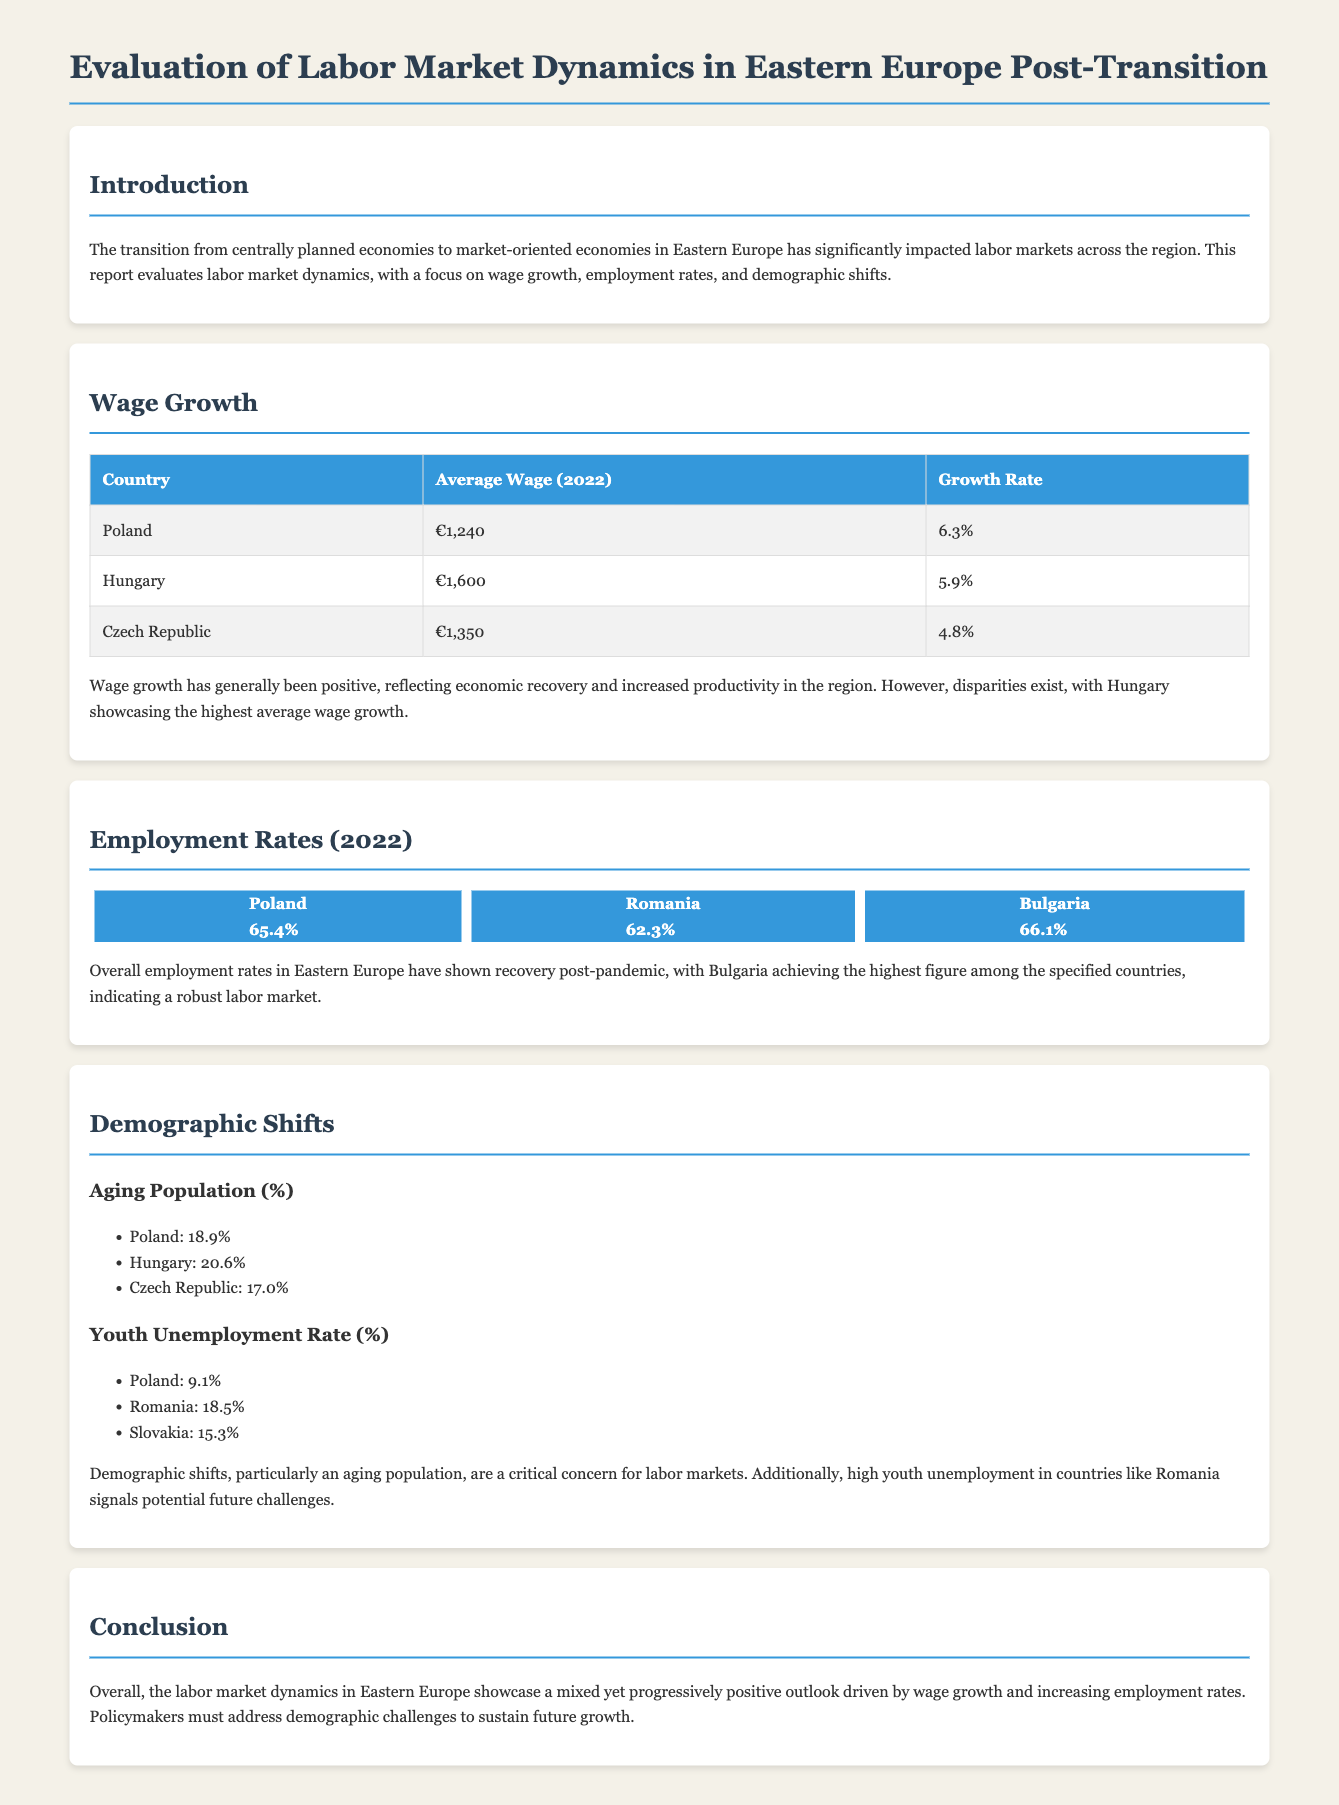What was the average wage in Poland in 2022? The average wage in Poland in 2022 is listed in the wage growth section.
Answer: €1,240 Which country had the highest average wage growth? The highest average wage growth is found in the table of wage growth data.
Answer: Hungary What is the employment rate in Bulgaria for 2022? The employment rate for Bulgaria is displayed in the chart section of the document.
Answer: 66.1% What percentage of the population in Hungary is aging? The aging population percentage for Hungary is provided in the demographic shifts section.
Answer: 20.6% What is the youth unemployment rate in Romania? The youth unemployment rate for Romania is mentioned under demographic shifts.
Answer: 18.5% How does the employment rate in Poland compare to Bulgaria? The comparison between employment rates requires evaluating both countries as presented in the chart.
Answer: Poland: 65.4%, Bulgaria: 66.1% What is the overall trend in wage growth across the region? This involves synthesizing information from the wage growth section regarding trends overall.
Answer: Positive What primary concern does the document highlight regarding demographics? The document emphasizes demographic shifts' impact on labor markets.
Answer: Aging population 